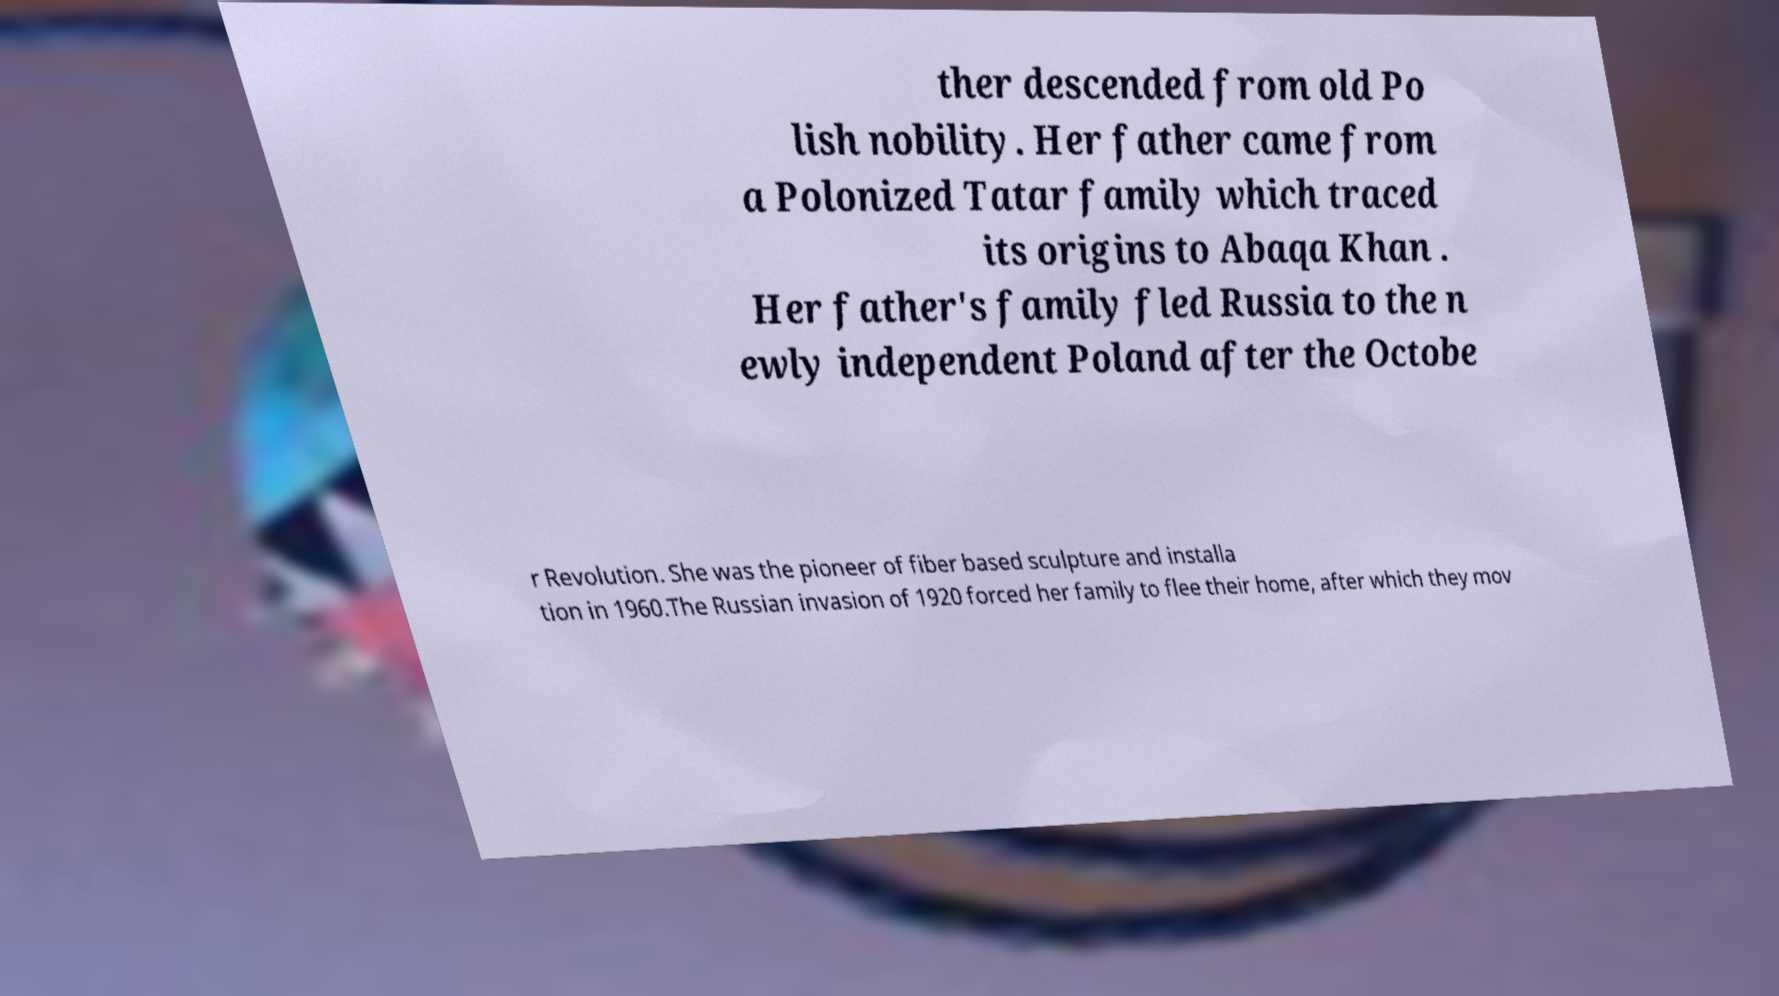Please identify and transcribe the text found in this image. ther descended from old Po lish nobility. Her father came from a Polonized Tatar family which traced its origins to Abaqa Khan . Her father's family fled Russia to the n ewly independent Poland after the Octobe r Revolution. She was the pioneer of fiber based sculpture and installa tion in 1960.The Russian invasion of 1920 forced her family to flee their home, after which they mov 